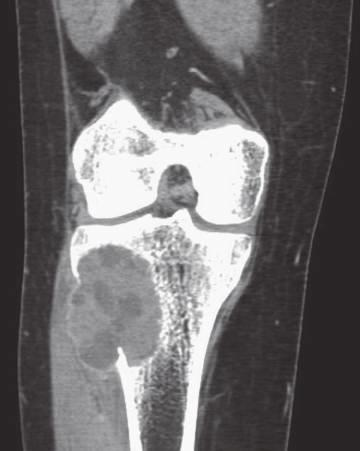what computed axial tomography scan shows eccentric aneurysmal bone cyst of tibia?
Answer the question using a single word or phrase. Coronal 